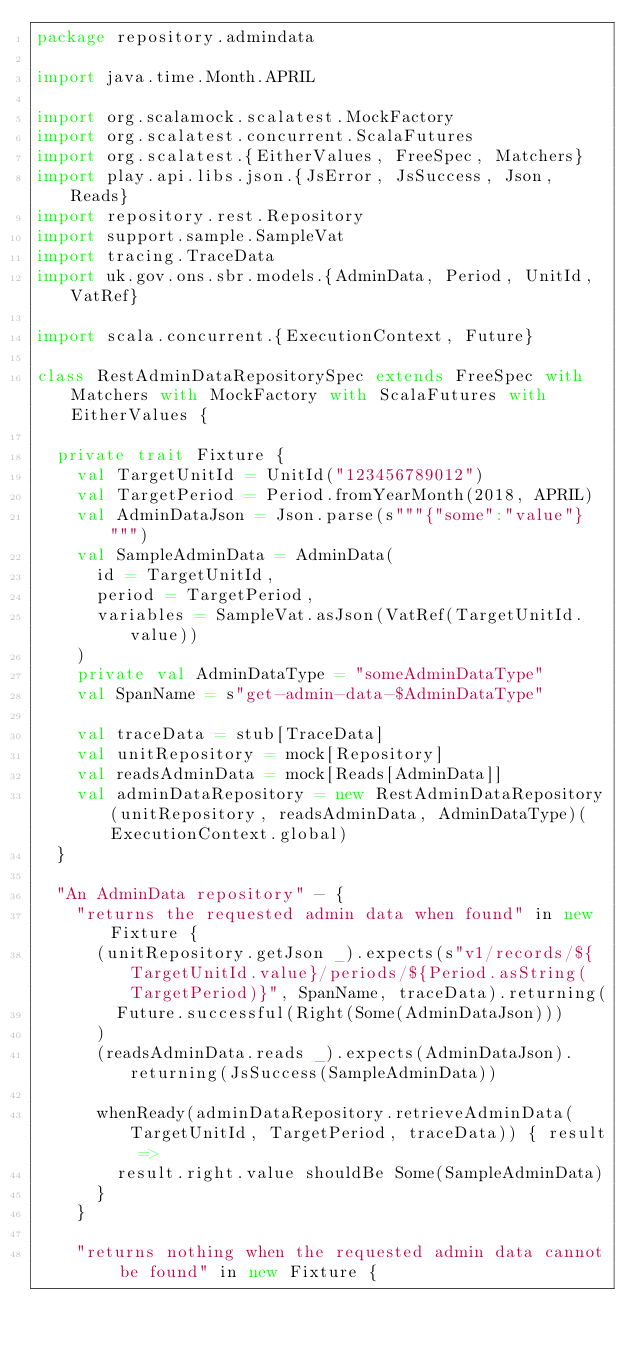<code> <loc_0><loc_0><loc_500><loc_500><_Scala_>package repository.admindata

import java.time.Month.APRIL

import org.scalamock.scalatest.MockFactory
import org.scalatest.concurrent.ScalaFutures
import org.scalatest.{EitherValues, FreeSpec, Matchers}
import play.api.libs.json.{JsError, JsSuccess, Json, Reads}
import repository.rest.Repository
import support.sample.SampleVat
import tracing.TraceData
import uk.gov.ons.sbr.models.{AdminData, Period, UnitId, VatRef}

import scala.concurrent.{ExecutionContext, Future}

class RestAdminDataRepositorySpec extends FreeSpec with Matchers with MockFactory with ScalaFutures with EitherValues {

  private trait Fixture {
    val TargetUnitId = UnitId("123456789012")
    val TargetPeriod = Period.fromYearMonth(2018, APRIL)
    val AdminDataJson = Json.parse(s"""{"some":"value"}""")
    val SampleAdminData = AdminData(
      id = TargetUnitId,
      period = TargetPeriod,
      variables = SampleVat.asJson(VatRef(TargetUnitId.value))
    )
    private val AdminDataType = "someAdminDataType"
    val SpanName = s"get-admin-data-$AdminDataType"

    val traceData = stub[TraceData]
    val unitRepository = mock[Repository]
    val readsAdminData = mock[Reads[AdminData]]
    val adminDataRepository = new RestAdminDataRepository(unitRepository, readsAdminData, AdminDataType)(ExecutionContext.global)
  }

  "An AdminData repository" - {
    "returns the requested admin data when found" in new Fixture {
      (unitRepository.getJson _).expects(s"v1/records/${TargetUnitId.value}/periods/${Period.asString(TargetPeriod)}", SpanName, traceData).returning(
        Future.successful(Right(Some(AdminDataJson)))
      )
      (readsAdminData.reads _).expects(AdminDataJson).returning(JsSuccess(SampleAdminData))

      whenReady(adminDataRepository.retrieveAdminData(TargetUnitId, TargetPeriod, traceData)) { result =>
        result.right.value shouldBe Some(SampleAdminData)
      }
    }

    "returns nothing when the requested admin data cannot be found" in new Fixture {</code> 